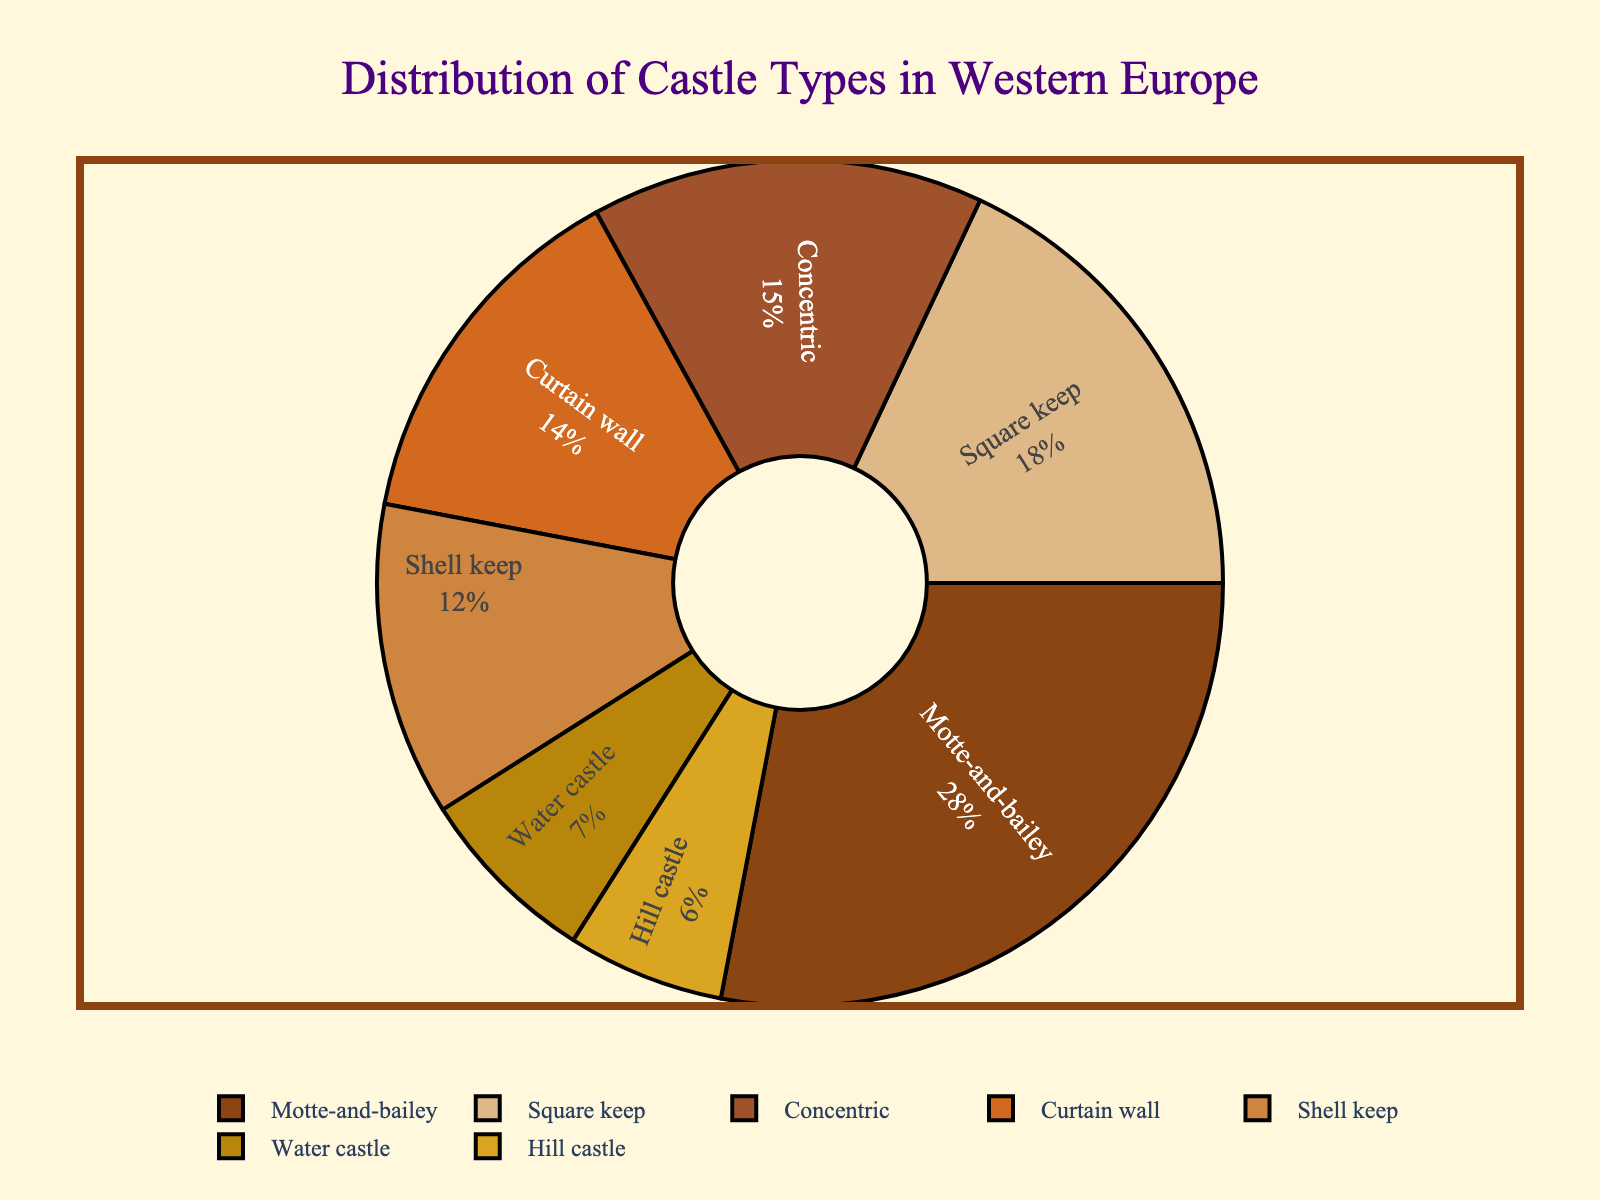Which castle type has the highest percentage distribution? The figure shows a pie chart with different segments representing various castle types and their corresponding percentages. By identifying the largest segment, we can see that Motte-and-bailey has the highest percentage at 28%.
Answer: Motte-and-bailey Which two castle types combined have a distribution of more than 30% but less than 50%? By adding the percentages of different castle types, we can find combinations that fall within the specified range. Concentric (15%) + Square keep (18%) = 33% and Curtain wall (14%) + Shell keep (12%) = 26%, indicating that Concentric and Square keep meet the criteria.
Answer: Concentric and Square keep How many castle types have a distribution greater than 10%? To solve this, count the segments of the pie chart that show percentages higher than 10%. Motte-and-bailey (28%), Square keep (18%), Concentric (15%), and Shell keep (12%) all fit this criterion. Therefore, there are four castle types with a distribution greater than 10%.
Answer: Four Which castle type has a 6% distribution? Inspect the labels of the pie chart for the castle type that matches a 6% distribution. The segment labeled "Hill castle" corresponds to this percentage.
Answer: Hill castle How much greater is the distribution of Motte-and-bailey compared to Water castle? Subtract the percentage of Water castle (7%) from the percentage of Motte-and-bailey (28%). The result is found by 28% - 7% = 21%.
Answer: 21% Which castle types have a similar visual appearance in terms of segment size and what are their percentages? Observe the pie chart segments and identify those that look similarly sized. Concentric (15%) and Curtain wall (14%) visually appear nearly the same in size.
Answer: Concentric and Curtain wall What is the total percentage of all castle types with a distribution less than 10%? Sum the percentages of castle types with distributions less than 10%, which includes Water castle (7%) and Hill castle (6%). Therefore, 7% + 6% = 13%.
Answer: 13% Which castle types have segments that are next to each other in the chart? Examine the arrangement of segments in the pie chart to identify which segments are adjacent. For instance, Shell keep (12%) and Square keep (18%) are next to each other.
Answer: Shell keep and Square keep 